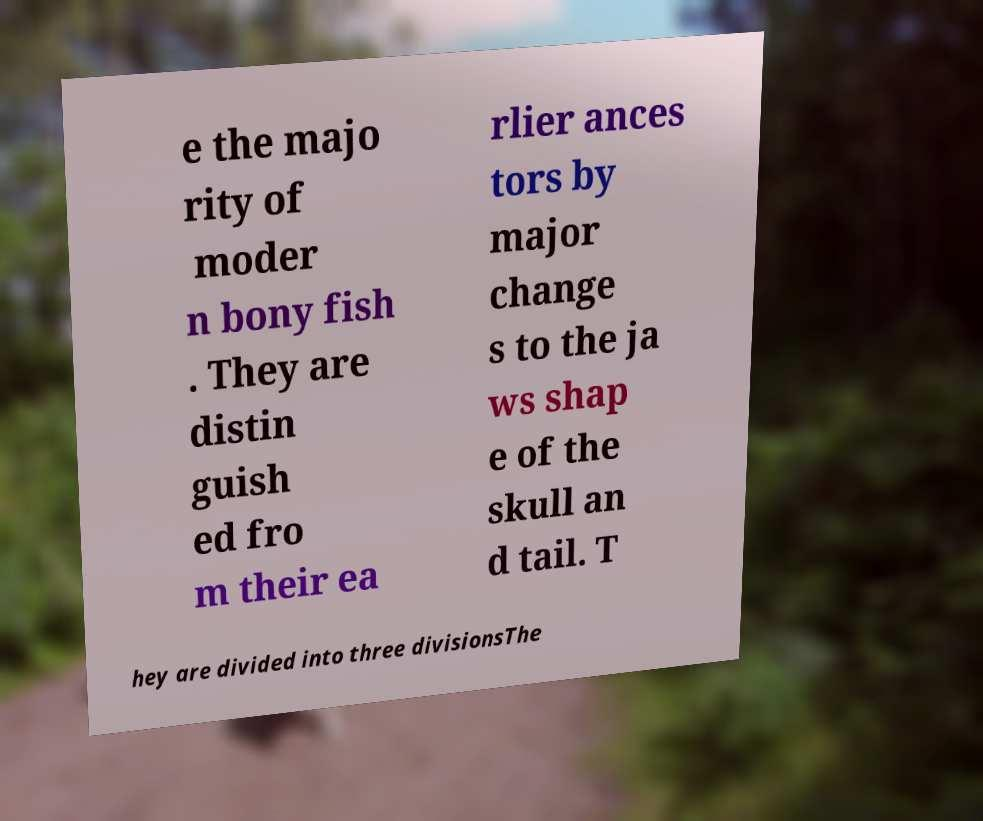For documentation purposes, I need the text within this image transcribed. Could you provide that? e the majo rity of moder n bony fish . They are distin guish ed fro m their ea rlier ances tors by major change s to the ja ws shap e of the skull an d tail. T hey are divided into three divisionsThe 